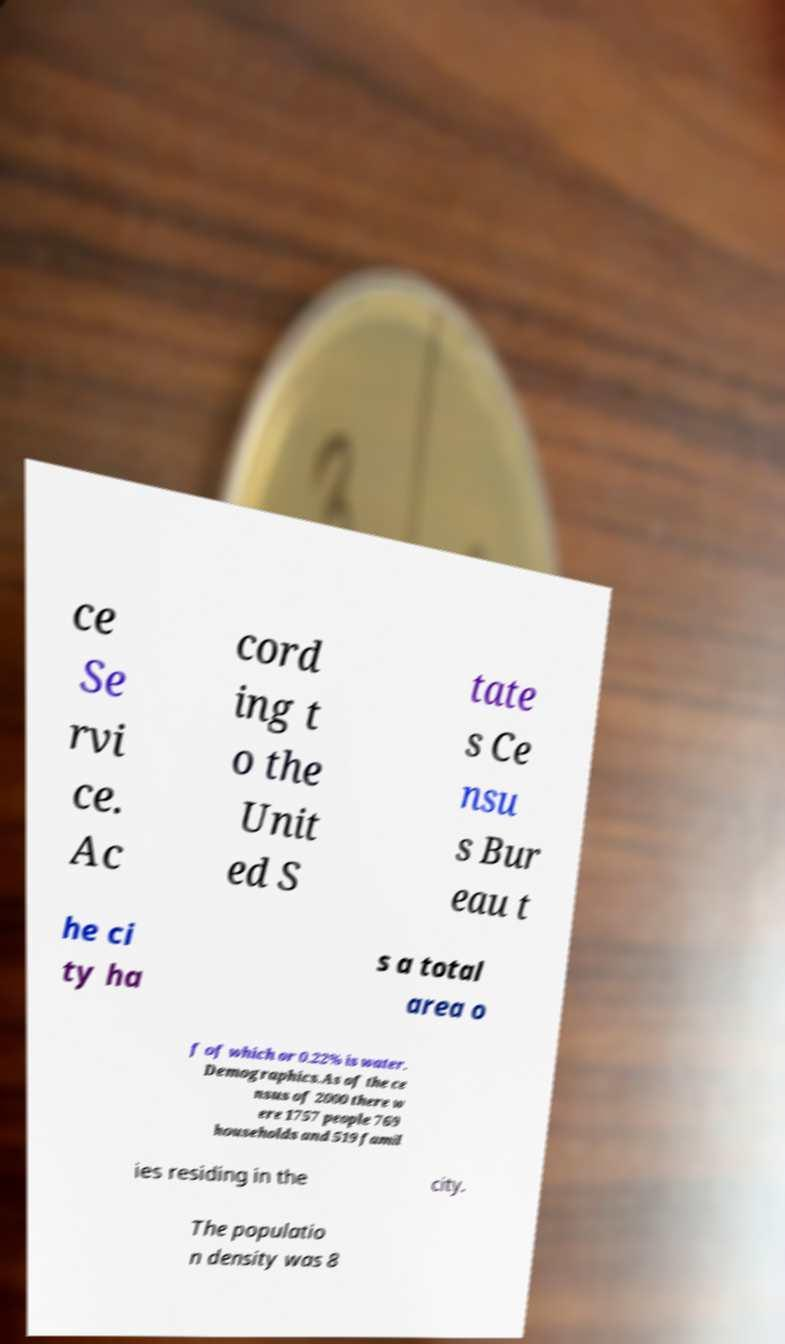For documentation purposes, I need the text within this image transcribed. Could you provide that? ce Se rvi ce. Ac cord ing t o the Unit ed S tate s Ce nsu s Bur eau t he ci ty ha s a total area o f of which or 0.22% is water. Demographics.As of the ce nsus of 2000 there w ere 1757 people 769 households and 519 famil ies residing in the city. The populatio n density was 8 